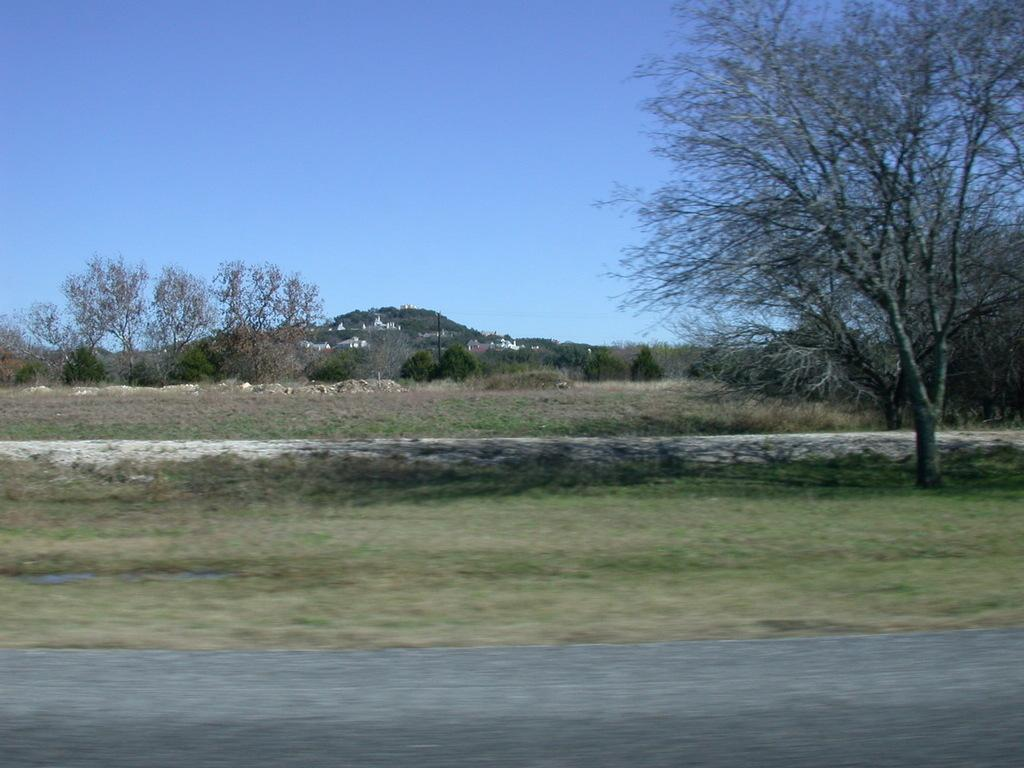What is the main feature of the image? There is a road in the image. What can be seen in the distance behind the road? There are buildings, trees, and the sky visible in the background of the image. What type of surface is at the bottom of the image? There is grass on the surface at the bottom of the image. What type of cup is being used by the police in the image? There is no cup or police present in the image. What government agency is responsible for maintaining the road in the image? The image does not provide information about the government agency responsible for maintaining the road. 